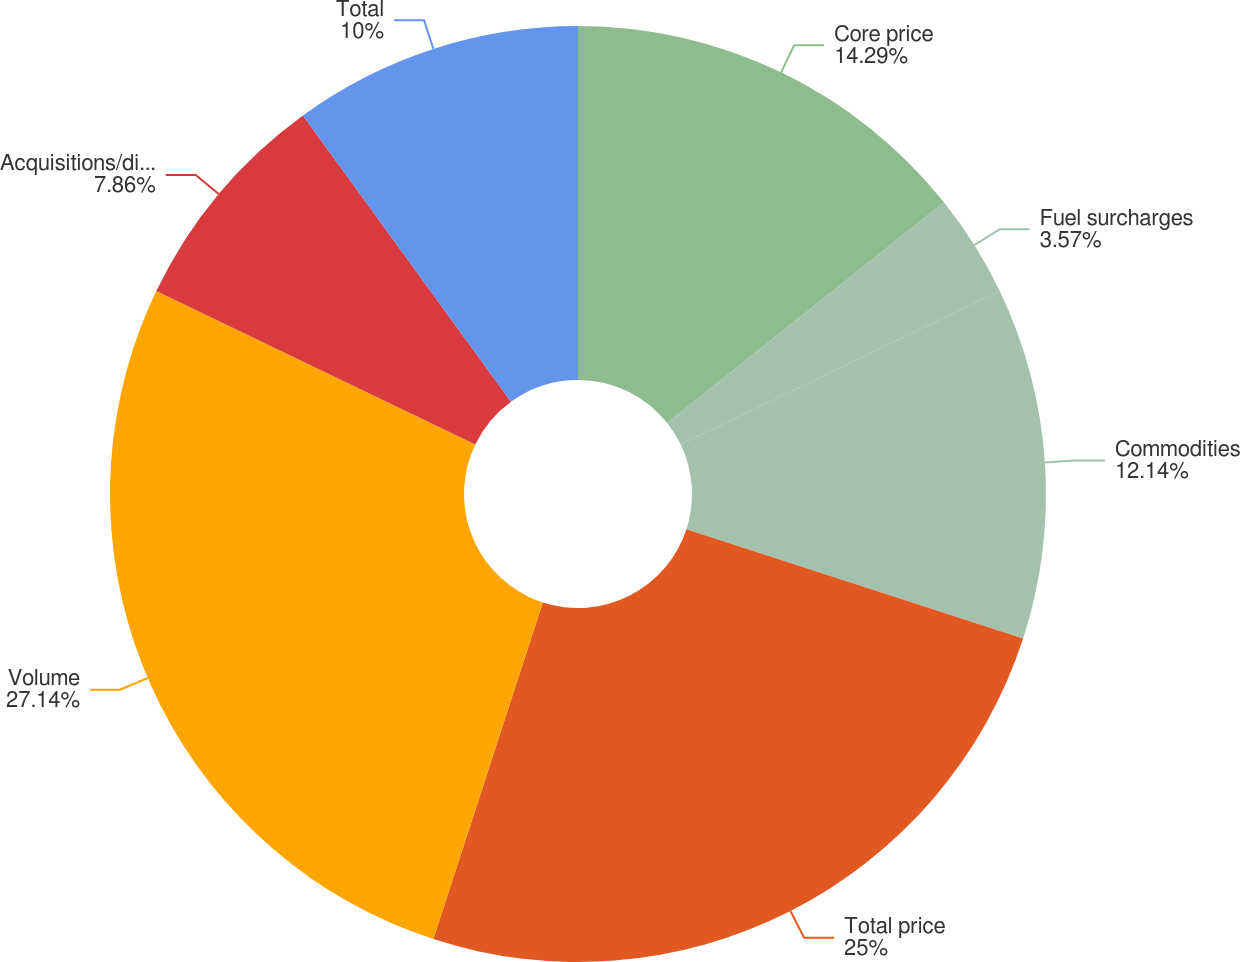Convert chart to OTSL. <chart><loc_0><loc_0><loc_500><loc_500><pie_chart><fcel>Core price<fcel>Fuel surcharges<fcel>Commodities<fcel>Total price<fcel>Volume<fcel>Acquisitions/divestitures net<fcel>Total<nl><fcel>14.29%<fcel>3.57%<fcel>12.14%<fcel>25.0%<fcel>27.14%<fcel>7.86%<fcel>10.0%<nl></chart> 